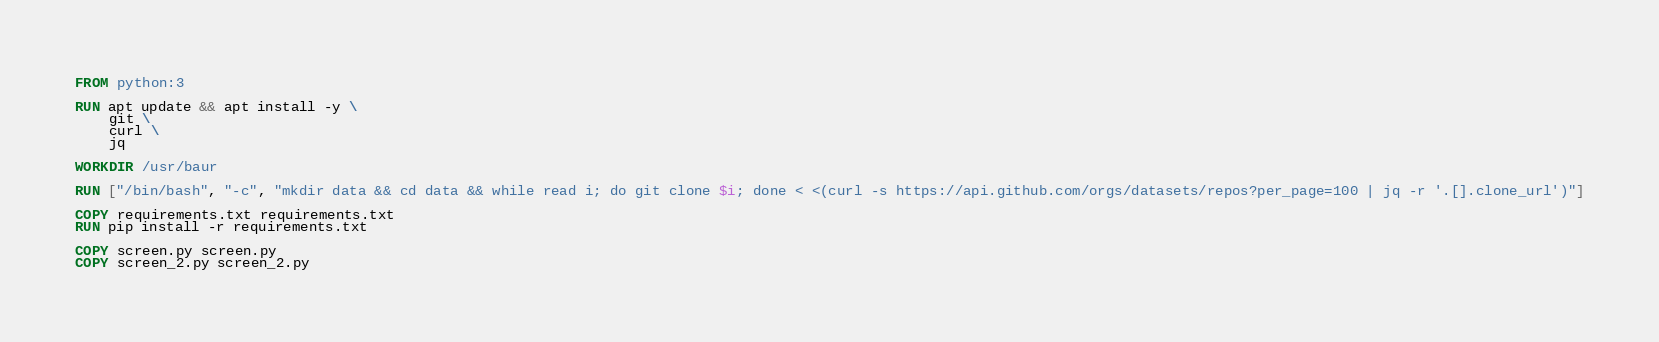<code> <loc_0><loc_0><loc_500><loc_500><_Dockerfile_>FROM python:3

RUN apt update && apt install -y \
    git \
    curl \
    jq

WORKDIR /usr/baur

RUN ["/bin/bash", "-c", "mkdir data && cd data && while read i; do git clone $i; done < <(curl -s https://api.github.com/orgs/datasets/repos?per_page=100 | jq -r '.[].clone_url')"]

COPY requirements.txt requirements.txt
RUN pip install -r requirements.txt

COPY screen.py screen.py
COPY screen_2.py screen_2.py
</code> 